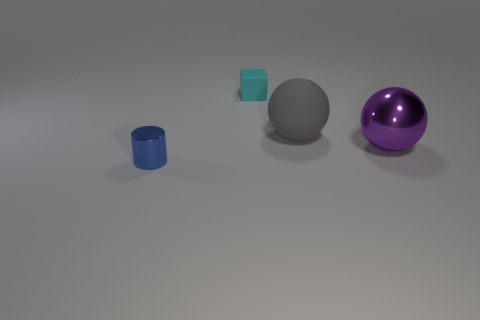There is a sphere that is behind the metal sphere in front of the tiny cyan cube; what is it made of?
Provide a short and direct response. Rubber. Are there more blue metal cylinders behind the matte cube than metallic spheres?
Offer a terse response. No. Are any purple metallic things visible?
Provide a short and direct response. Yes. There is a sphere that is behind the purple shiny thing; what color is it?
Keep it short and to the point. Gray. There is a gray ball that is the same size as the purple thing; what material is it?
Provide a short and direct response. Rubber. How many other objects are the same material as the cylinder?
Give a very brief answer. 1. The thing that is to the right of the cyan matte cube and behind the purple object is what color?
Your answer should be very brief. Gray. How many things are either shiny things behind the tiny blue cylinder or big purple spheres?
Your answer should be very brief. 1. What number of other objects are the same color as the tiny rubber object?
Offer a very short reply. 0. Are there the same number of tiny objects right of the purple thing and purple metallic things?
Keep it short and to the point. No. 